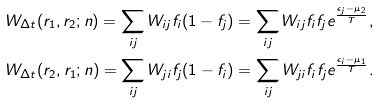<formula> <loc_0><loc_0><loc_500><loc_500>W _ { \Delta t } ( r _ { 1 } , r _ { 2 } ; n ) = \sum _ { i j } W _ { i j } f _ { i } ( 1 - f _ { j } ) = \sum _ { i j } W _ { i j } f _ { i } f _ { j } e ^ { \frac { \epsilon _ { j } - \mu _ { 2 } } { T } } , \\ W _ { \Delta t } ( r _ { 2 } , r _ { 1 } ; n ) = \sum _ { i j } W _ { j i } f _ { j } ( 1 - f _ { i } ) = \sum _ { i j } W _ { j i } f _ { i } f _ { j } e ^ { \frac { \epsilon _ { i } - \mu _ { 1 } } { T } } .</formula> 